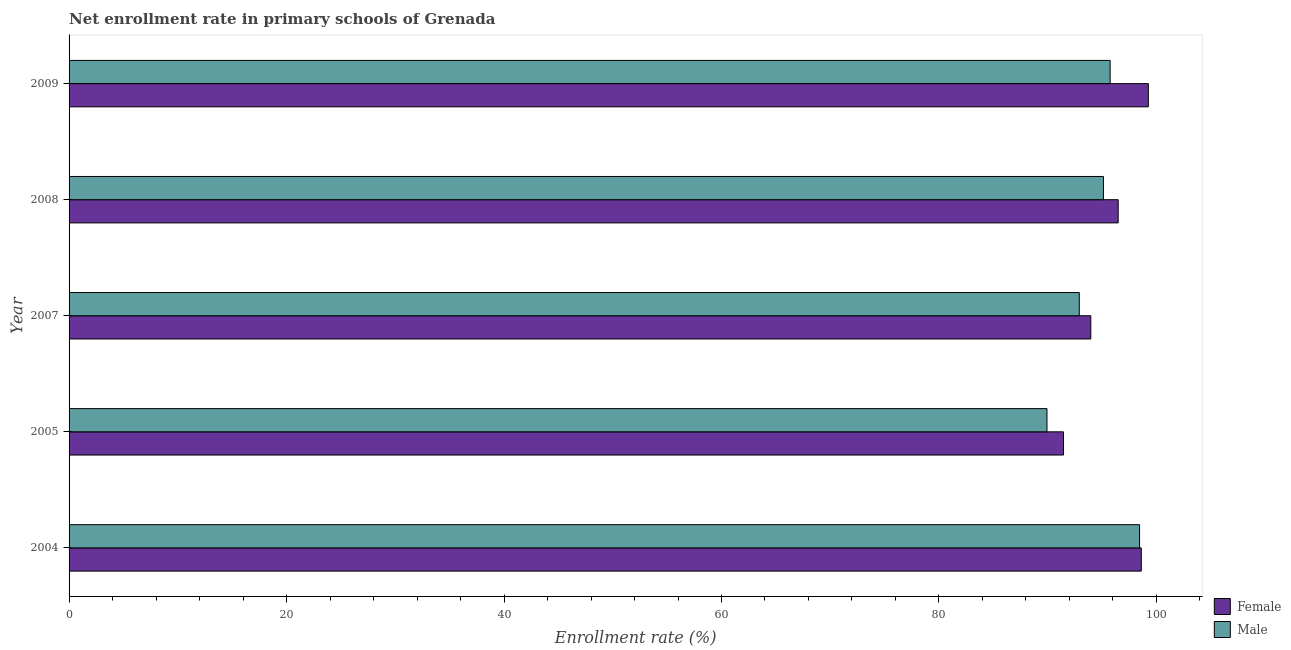Are the number of bars per tick equal to the number of legend labels?
Your answer should be very brief. Yes. Are the number of bars on each tick of the Y-axis equal?
Your answer should be very brief. Yes. How many bars are there on the 5th tick from the bottom?
Keep it short and to the point. 2. In how many cases, is the number of bars for a given year not equal to the number of legend labels?
Give a very brief answer. 0. What is the enrollment rate of male students in 2005?
Your answer should be very brief. 89.93. Across all years, what is the maximum enrollment rate of female students?
Your answer should be compact. 99.25. Across all years, what is the minimum enrollment rate of male students?
Your response must be concise. 89.93. In which year was the enrollment rate of male students maximum?
Your response must be concise. 2004. In which year was the enrollment rate of male students minimum?
Provide a short and direct response. 2005. What is the total enrollment rate of male students in the graph?
Your answer should be very brief. 472.15. What is the difference between the enrollment rate of male students in 2004 and that in 2008?
Ensure brevity in your answer.  3.32. What is the difference between the enrollment rate of female students in 2005 and the enrollment rate of male students in 2008?
Offer a terse response. -3.67. What is the average enrollment rate of female students per year?
Make the answer very short. 95.95. In the year 2009, what is the difference between the enrollment rate of female students and enrollment rate of male students?
Offer a terse response. 3.51. What is the ratio of the enrollment rate of female students in 2004 to that in 2008?
Your response must be concise. 1.02. What is the difference between the highest and the second highest enrollment rate of female students?
Make the answer very short. 0.65. What is the difference between the highest and the lowest enrollment rate of female students?
Provide a short and direct response. 7.8. What does the 2nd bar from the top in 2005 represents?
Provide a short and direct response. Female. Are all the bars in the graph horizontal?
Give a very brief answer. Yes. What is the difference between two consecutive major ticks on the X-axis?
Provide a short and direct response. 20. Are the values on the major ticks of X-axis written in scientific E-notation?
Make the answer very short. No. Does the graph contain any zero values?
Make the answer very short. No. Where does the legend appear in the graph?
Ensure brevity in your answer.  Bottom right. How are the legend labels stacked?
Keep it short and to the point. Vertical. What is the title of the graph?
Your answer should be compact. Net enrollment rate in primary schools of Grenada. Does "Investments" appear as one of the legend labels in the graph?
Your answer should be very brief. No. What is the label or title of the X-axis?
Provide a succinct answer. Enrollment rate (%). What is the Enrollment rate (%) of Female in 2004?
Make the answer very short. 98.61. What is the Enrollment rate (%) of Male in 2004?
Your response must be concise. 98.45. What is the Enrollment rate (%) of Female in 2005?
Ensure brevity in your answer.  91.45. What is the Enrollment rate (%) in Male in 2005?
Keep it short and to the point. 89.93. What is the Enrollment rate (%) in Female in 2007?
Provide a short and direct response. 93.96. What is the Enrollment rate (%) in Male in 2007?
Your response must be concise. 92.9. What is the Enrollment rate (%) of Female in 2008?
Give a very brief answer. 96.48. What is the Enrollment rate (%) in Male in 2008?
Your response must be concise. 95.13. What is the Enrollment rate (%) in Female in 2009?
Your answer should be very brief. 99.25. What is the Enrollment rate (%) in Male in 2009?
Offer a very short reply. 95.74. Across all years, what is the maximum Enrollment rate (%) in Female?
Offer a very short reply. 99.25. Across all years, what is the maximum Enrollment rate (%) in Male?
Give a very brief answer. 98.45. Across all years, what is the minimum Enrollment rate (%) in Female?
Offer a terse response. 91.45. Across all years, what is the minimum Enrollment rate (%) in Male?
Provide a short and direct response. 89.93. What is the total Enrollment rate (%) in Female in the graph?
Give a very brief answer. 479.76. What is the total Enrollment rate (%) in Male in the graph?
Your answer should be compact. 472.15. What is the difference between the Enrollment rate (%) of Female in 2004 and that in 2005?
Offer a very short reply. 7.16. What is the difference between the Enrollment rate (%) in Male in 2004 and that in 2005?
Keep it short and to the point. 8.51. What is the difference between the Enrollment rate (%) of Female in 2004 and that in 2007?
Keep it short and to the point. 4.64. What is the difference between the Enrollment rate (%) of Male in 2004 and that in 2007?
Make the answer very short. 5.54. What is the difference between the Enrollment rate (%) in Female in 2004 and that in 2008?
Make the answer very short. 2.13. What is the difference between the Enrollment rate (%) in Male in 2004 and that in 2008?
Provide a short and direct response. 3.32. What is the difference between the Enrollment rate (%) of Female in 2004 and that in 2009?
Ensure brevity in your answer.  -0.65. What is the difference between the Enrollment rate (%) in Male in 2004 and that in 2009?
Keep it short and to the point. 2.71. What is the difference between the Enrollment rate (%) in Female in 2005 and that in 2007?
Offer a terse response. -2.51. What is the difference between the Enrollment rate (%) of Male in 2005 and that in 2007?
Ensure brevity in your answer.  -2.97. What is the difference between the Enrollment rate (%) in Female in 2005 and that in 2008?
Keep it short and to the point. -5.03. What is the difference between the Enrollment rate (%) in Male in 2005 and that in 2008?
Keep it short and to the point. -5.19. What is the difference between the Enrollment rate (%) in Female in 2005 and that in 2009?
Keep it short and to the point. -7.8. What is the difference between the Enrollment rate (%) in Male in 2005 and that in 2009?
Give a very brief answer. -5.81. What is the difference between the Enrollment rate (%) of Female in 2007 and that in 2008?
Offer a terse response. -2.52. What is the difference between the Enrollment rate (%) in Male in 2007 and that in 2008?
Keep it short and to the point. -2.22. What is the difference between the Enrollment rate (%) in Female in 2007 and that in 2009?
Your answer should be very brief. -5.29. What is the difference between the Enrollment rate (%) in Male in 2007 and that in 2009?
Your answer should be very brief. -2.84. What is the difference between the Enrollment rate (%) of Female in 2008 and that in 2009?
Provide a succinct answer. -2.77. What is the difference between the Enrollment rate (%) in Male in 2008 and that in 2009?
Offer a very short reply. -0.62. What is the difference between the Enrollment rate (%) in Female in 2004 and the Enrollment rate (%) in Male in 2005?
Offer a terse response. 8.67. What is the difference between the Enrollment rate (%) in Female in 2004 and the Enrollment rate (%) in Male in 2007?
Your answer should be compact. 5.7. What is the difference between the Enrollment rate (%) in Female in 2004 and the Enrollment rate (%) in Male in 2008?
Offer a terse response. 3.48. What is the difference between the Enrollment rate (%) in Female in 2004 and the Enrollment rate (%) in Male in 2009?
Offer a terse response. 2.87. What is the difference between the Enrollment rate (%) of Female in 2005 and the Enrollment rate (%) of Male in 2007?
Ensure brevity in your answer.  -1.45. What is the difference between the Enrollment rate (%) of Female in 2005 and the Enrollment rate (%) of Male in 2008?
Your answer should be compact. -3.67. What is the difference between the Enrollment rate (%) in Female in 2005 and the Enrollment rate (%) in Male in 2009?
Offer a very short reply. -4.29. What is the difference between the Enrollment rate (%) in Female in 2007 and the Enrollment rate (%) in Male in 2008?
Provide a succinct answer. -1.16. What is the difference between the Enrollment rate (%) in Female in 2007 and the Enrollment rate (%) in Male in 2009?
Ensure brevity in your answer.  -1.78. What is the difference between the Enrollment rate (%) of Female in 2008 and the Enrollment rate (%) of Male in 2009?
Your answer should be compact. 0.74. What is the average Enrollment rate (%) in Female per year?
Offer a very short reply. 95.95. What is the average Enrollment rate (%) in Male per year?
Offer a very short reply. 94.43. In the year 2004, what is the difference between the Enrollment rate (%) of Female and Enrollment rate (%) of Male?
Offer a very short reply. 0.16. In the year 2005, what is the difference between the Enrollment rate (%) in Female and Enrollment rate (%) in Male?
Your response must be concise. 1.52. In the year 2007, what is the difference between the Enrollment rate (%) in Female and Enrollment rate (%) in Male?
Give a very brief answer. 1.06. In the year 2008, what is the difference between the Enrollment rate (%) of Female and Enrollment rate (%) of Male?
Your answer should be compact. 1.36. In the year 2009, what is the difference between the Enrollment rate (%) of Female and Enrollment rate (%) of Male?
Give a very brief answer. 3.51. What is the ratio of the Enrollment rate (%) of Female in 2004 to that in 2005?
Ensure brevity in your answer.  1.08. What is the ratio of the Enrollment rate (%) of Male in 2004 to that in 2005?
Ensure brevity in your answer.  1.09. What is the ratio of the Enrollment rate (%) in Female in 2004 to that in 2007?
Offer a very short reply. 1.05. What is the ratio of the Enrollment rate (%) of Male in 2004 to that in 2007?
Provide a short and direct response. 1.06. What is the ratio of the Enrollment rate (%) of Female in 2004 to that in 2008?
Your answer should be very brief. 1.02. What is the ratio of the Enrollment rate (%) in Male in 2004 to that in 2008?
Your answer should be very brief. 1.03. What is the ratio of the Enrollment rate (%) of Male in 2004 to that in 2009?
Your response must be concise. 1.03. What is the ratio of the Enrollment rate (%) in Female in 2005 to that in 2007?
Your answer should be very brief. 0.97. What is the ratio of the Enrollment rate (%) in Male in 2005 to that in 2007?
Provide a succinct answer. 0.97. What is the ratio of the Enrollment rate (%) of Female in 2005 to that in 2008?
Keep it short and to the point. 0.95. What is the ratio of the Enrollment rate (%) of Male in 2005 to that in 2008?
Make the answer very short. 0.95. What is the ratio of the Enrollment rate (%) of Female in 2005 to that in 2009?
Offer a very short reply. 0.92. What is the ratio of the Enrollment rate (%) in Male in 2005 to that in 2009?
Provide a succinct answer. 0.94. What is the ratio of the Enrollment rate (%) in Female in 2007 to that in 2008?
Provide a short and direct response. 0.97. What is the ratio of the Enrollment rate (%) of Male in 2007 to that in 2008?
Offer a very short reply. 0.98. What is the ratio of the Enrollment rate (%) in Female in 2007 to that in 2009?
Provide a short and direct response. 0.95. What is the ratio of the Enrollment rate (%) of Male in 2007 to that in 2009?
Your answer should be very brief. 0.97. What is the ratio of the Enrollment rate (%) of Female in 2008 to that in 2009?
Offer a terse response. 0.97. What is the difference between the highest and the second highest Enrollment rate (%) in Female?
Offer a very short reply. 0.65. What is the difference between the highest and the second highest Enrollment rate (%) of Male?
Offer a terse response. 2.71. What is the difference between the highest and the lowest Enrollment rate (%) in Female?
Your answer should be compact. 7.8. What is the difference between the highest and the lowest Enrollment rate (%) of Male?
Provide a succinct answer. 8.51. 